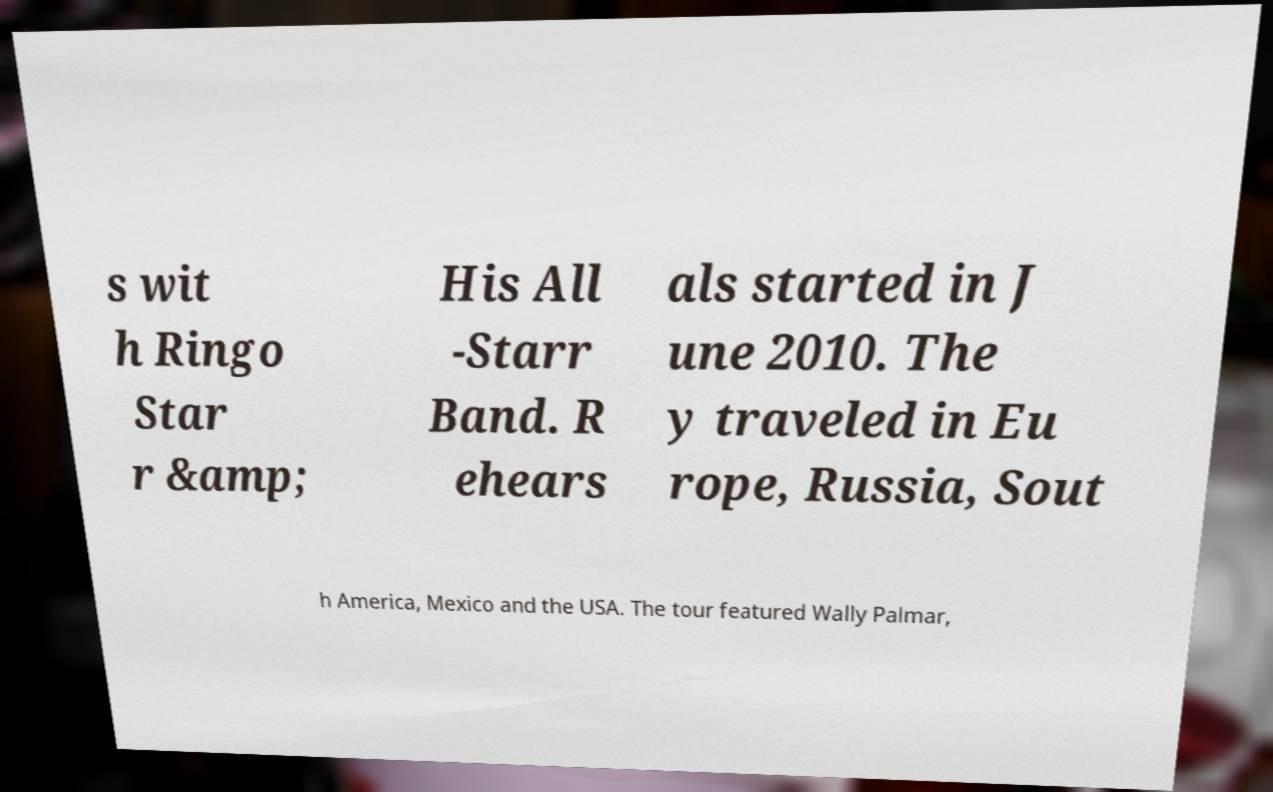Could you extract and type out the text from this image? s wit h Ringo Star r &amp; His All -Starr Band. R ehears als started in J une 2010. The y traveled in Eu rope, Russia, Sout h America, Mexico and the USA. The tour featured Wally Palmar, 